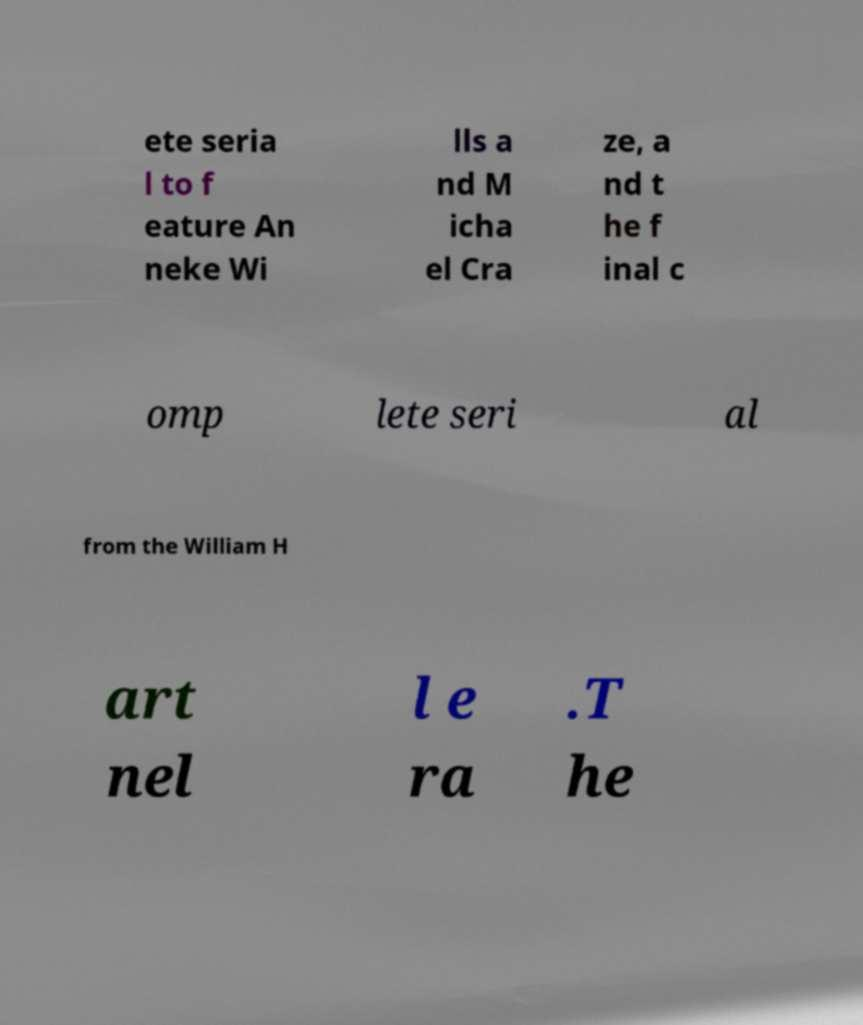For documentation purposes, I need the text within this image transcribed. Could you provide that? ete seria l to f eature An neke Wi lls a nd M icha el Cra ze, a nd t he f inal c omp lete seri al from the William H art nel l e ra .T he 